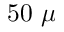<formula> <loc_0><loc_0><loc_500><loc_500>5 0 \mu</formula> 